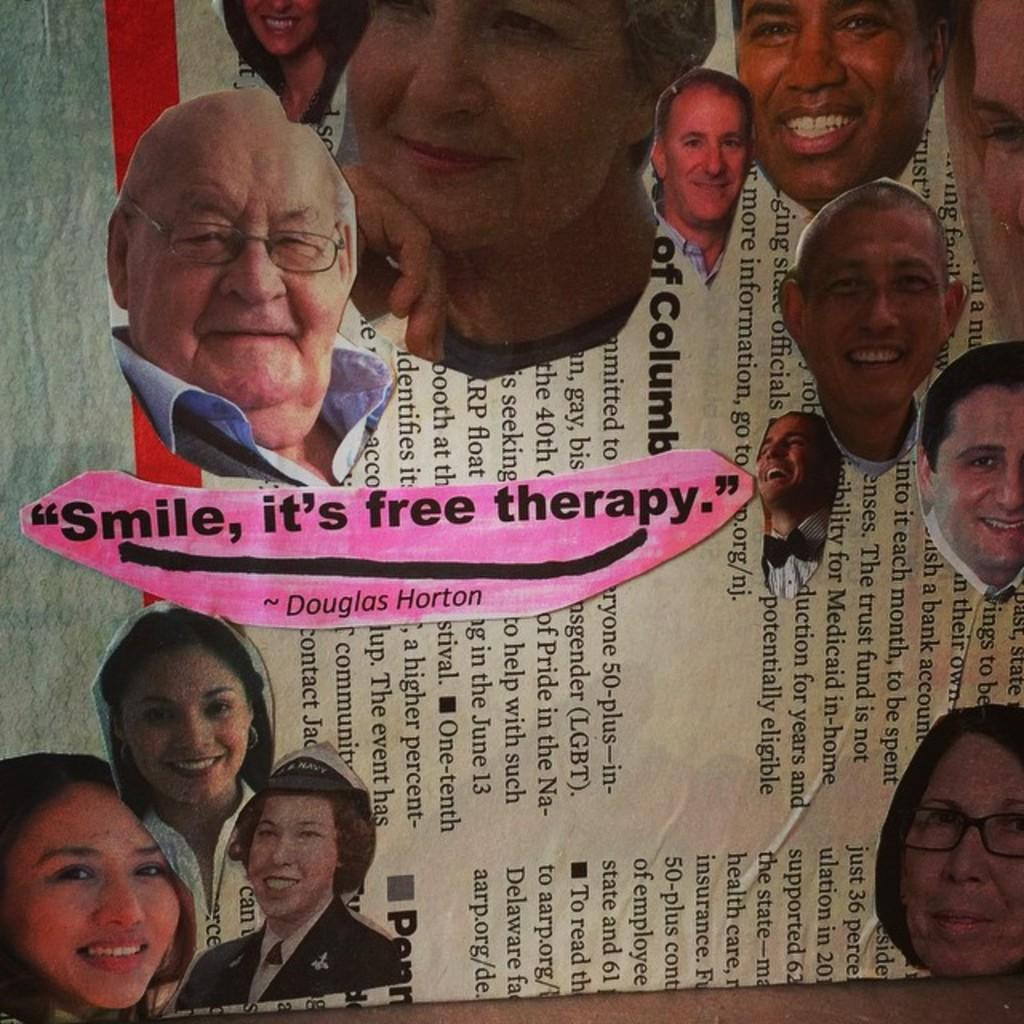What is depicted in the image? There are photos of people in the image. What is the medium on which the photos are displayed? The photos are on a paper. What is the profit generated from the photos in the image? There is no information about profit in the image, as it only shows photos of people on a paper. 